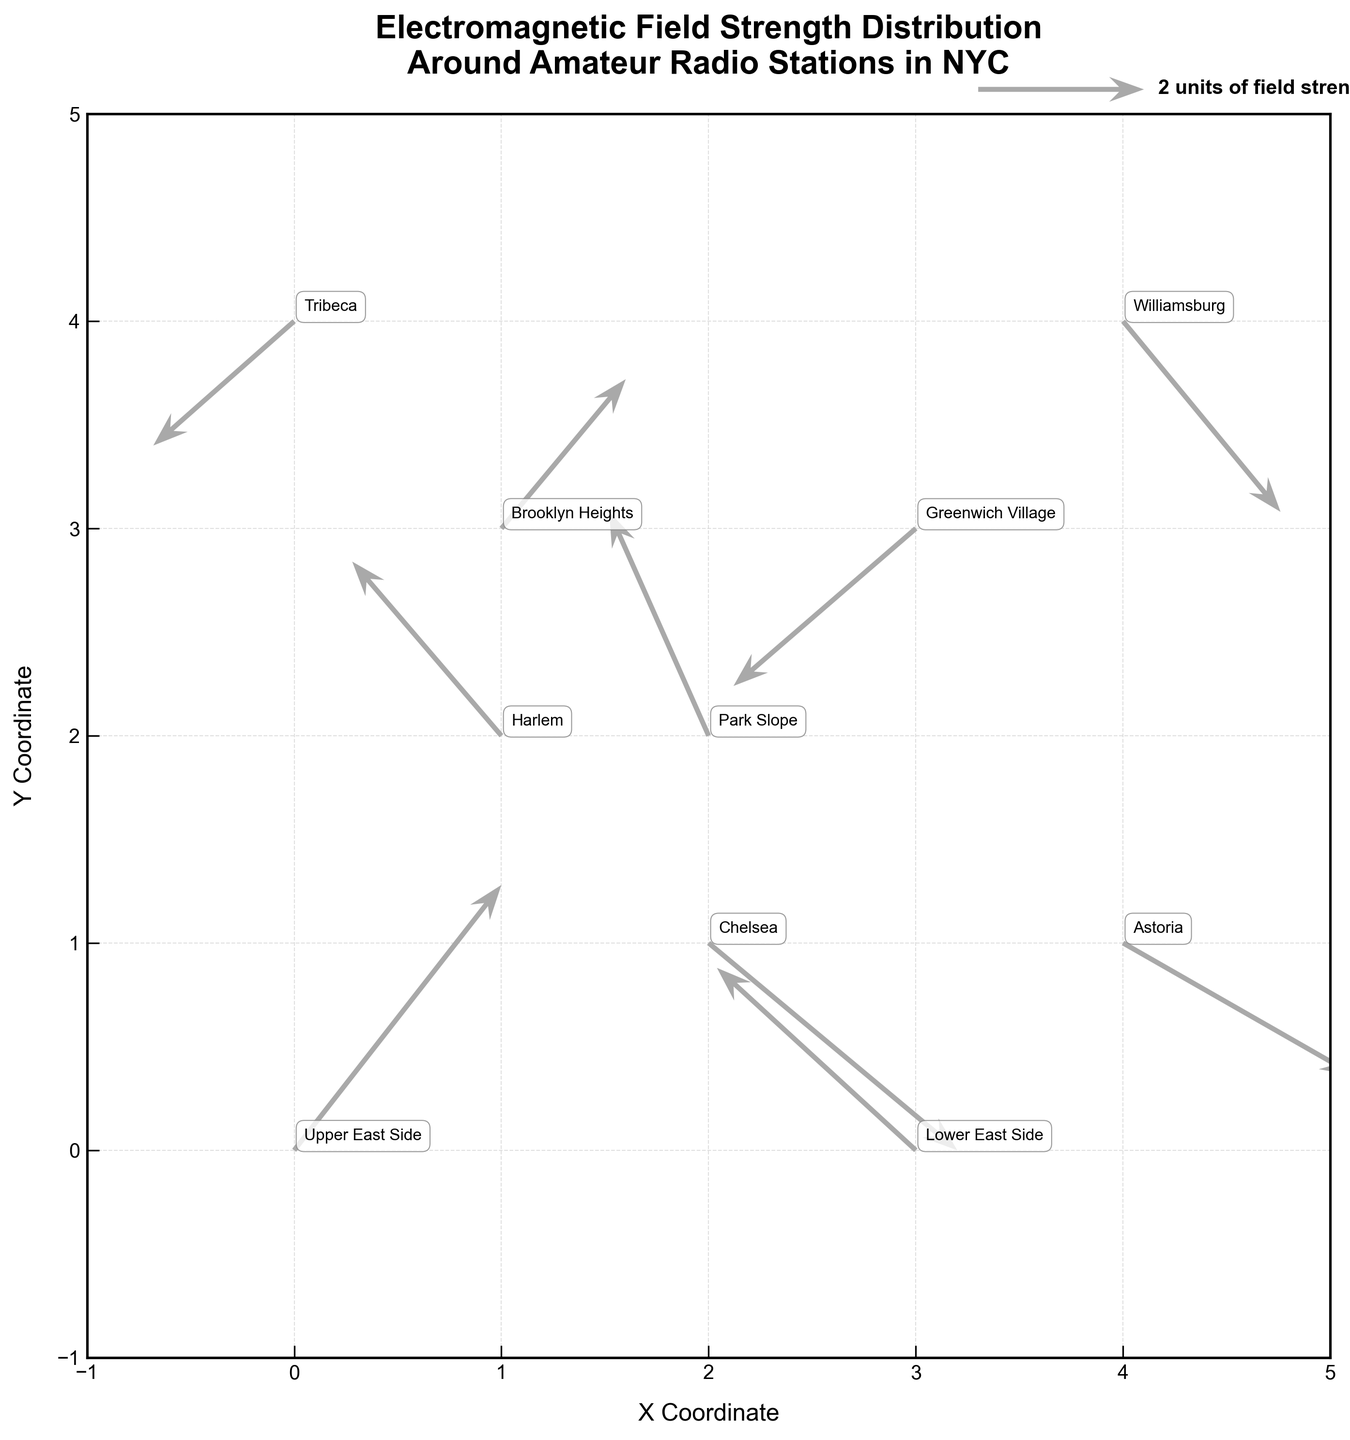What is the title of the figure? The title of the figure is located at the top and provides the main description of what is being visualized. It helps the viewer understand the primary focus of the plot.
Answer: Electromagnetic Field Strength Distribution Around Amateur Radio Stations in NYC How many neighborhoods are visualized in the plot? By counting the number of unique labels associated with different points on the plot, we can determine the number of neighborhoods visualized.
Answer: 10 Which neighborhood has a vector pointing in the positive x and positive y direction? To find this, look for vectors that point to the top-right quadrant, which indicates both x and y components are positive.
Answer: Upper East Side and Brooklyn Heights What is the direction of the field strength vector for Williamsburg? Observe the vector emanating from Williamsburg's coordinates to see in which quadrant or direction it points. The positive or negative values on both axes will define this direction.
Answer: Positive x, negative y Between Chelsea and Park Slope, which neighborhood has a vector with a larger magnitude? Calculate the magnitudes using the formula √(u² + v²) for both neighborhoods and compare them.
Answer: Chelsea Which vector has the greatest horizontal field strength component? Compare the absolute values of the u-components (horizontal components) of each vector to identify the largest.
Answer: Chelsea Calculate the magnitude of the field strength vector for Astoria. Use the formula √(u² + v²) to compute the magnitude. For Astoria: √(2.8² + (-1.6)²) = √(7.84 + 2.56). So the magnitude ≈ √10.4 ≈ 3.22.
Answer: 3.22 Find the neighborhood with the smallest vertical field strength component. Compare the absolute values of the v-components (vertical components) for each vector to identify the smallest.
Answer: Tribeca Which neighborhoods have vectors in the negative x and positive y directions? Look for vectors where the u-components are negative and the v-components are positive.
Answer: Harlem and Park Slope Identify the neighborhood with a vector pointing directly downwards. A vector pointing directly downwards will have no horizontal component (u = 0), and a negative vertical component (v < 0).
Answer: None 